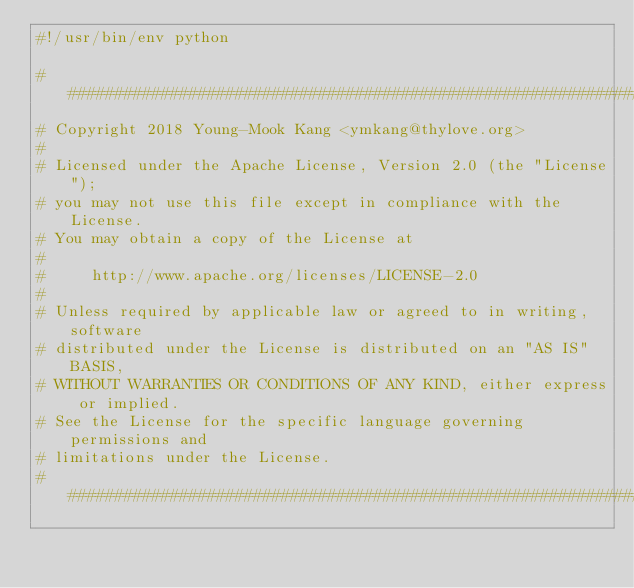Convert code to text. <code><loc_0><loc_0><loc_500><loc_500><_Python_>#!/usr/bin/env python

################################################################################
# Copyright 2018 Young-Mook Kang <ymkang@thylove.org>
#
# Licensed under the Apache License, Version 2.0 (the "License");
# you may not use this file except in compliance with the License.
# You may obtain a copy of the License at
#
#     http://www.apache.org/licenses/LICENSE-2.0
#
# Unless required by applicable law or agreed to in writing, software
# distributed under the License is distributed on an "AS IS" BASIS,
# WITHOUT WARRANTIES OR CONDITIONS OF ANY KIND, either express or implied.
# See the License for the specific language governing permissions and
# limitations under the License.
################################################################################
</code> 